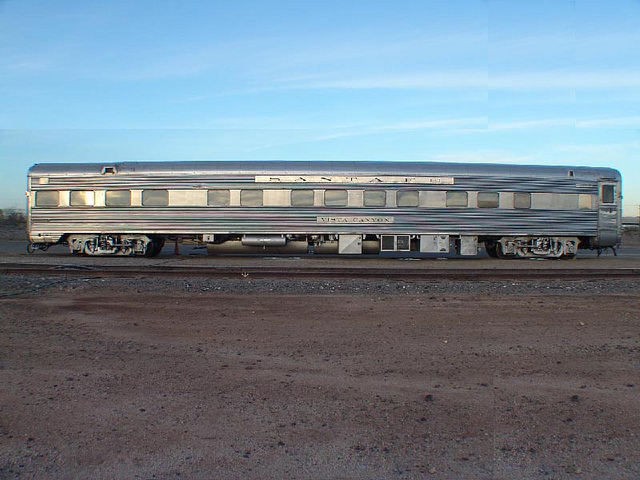Please transcribe the text information in this image. VINTA CANNON 